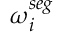Convert formula to latex. <formula><loc_0><loc_0><loc_500><loc_500>\omega _ { i } ^ { s e g }</formula> 